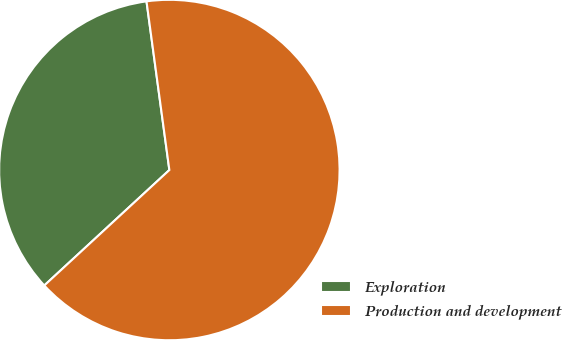<chart> <loc_0><loc_0><loc_500><loc_500><pie_chart><fcel>Exploration<fcel>Production and development<nl><fcel>34.72%<fcel>65.28%<nl></chart> 